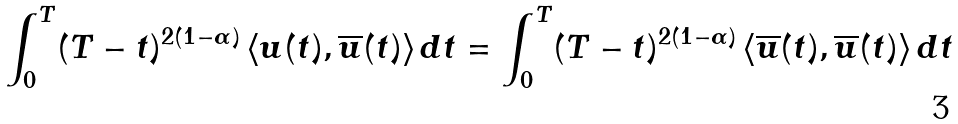Convert formula to latex. <formula><loc_0><loc_0><loc_500><loc_500>\int _ { 0 } ^ { T } ( T - t ) ^ { 2 ( 1 - \alpha ) } \left < u ( t ) , \overline { u } ( t ) \right > d t = \int _ { 0 } ^ { T } ( T - t ) ^ { 2 ( 1 - \alpha ) } \left < \overline { u } ( t ) , \overline { u } ( t ) \right > d t</formula> 